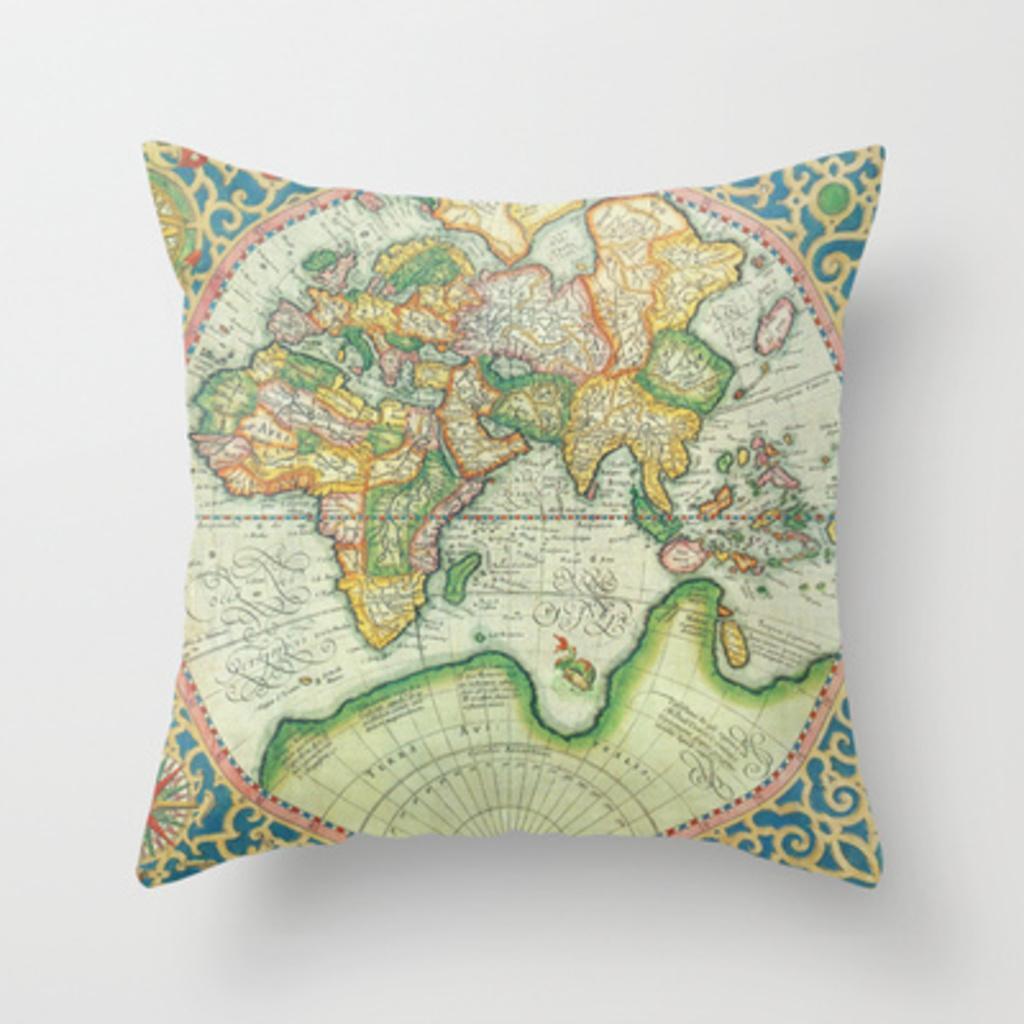How would you summarize this image in a sentence or two? This picture shows a cushion and we see a map on it and its background is white in color. 